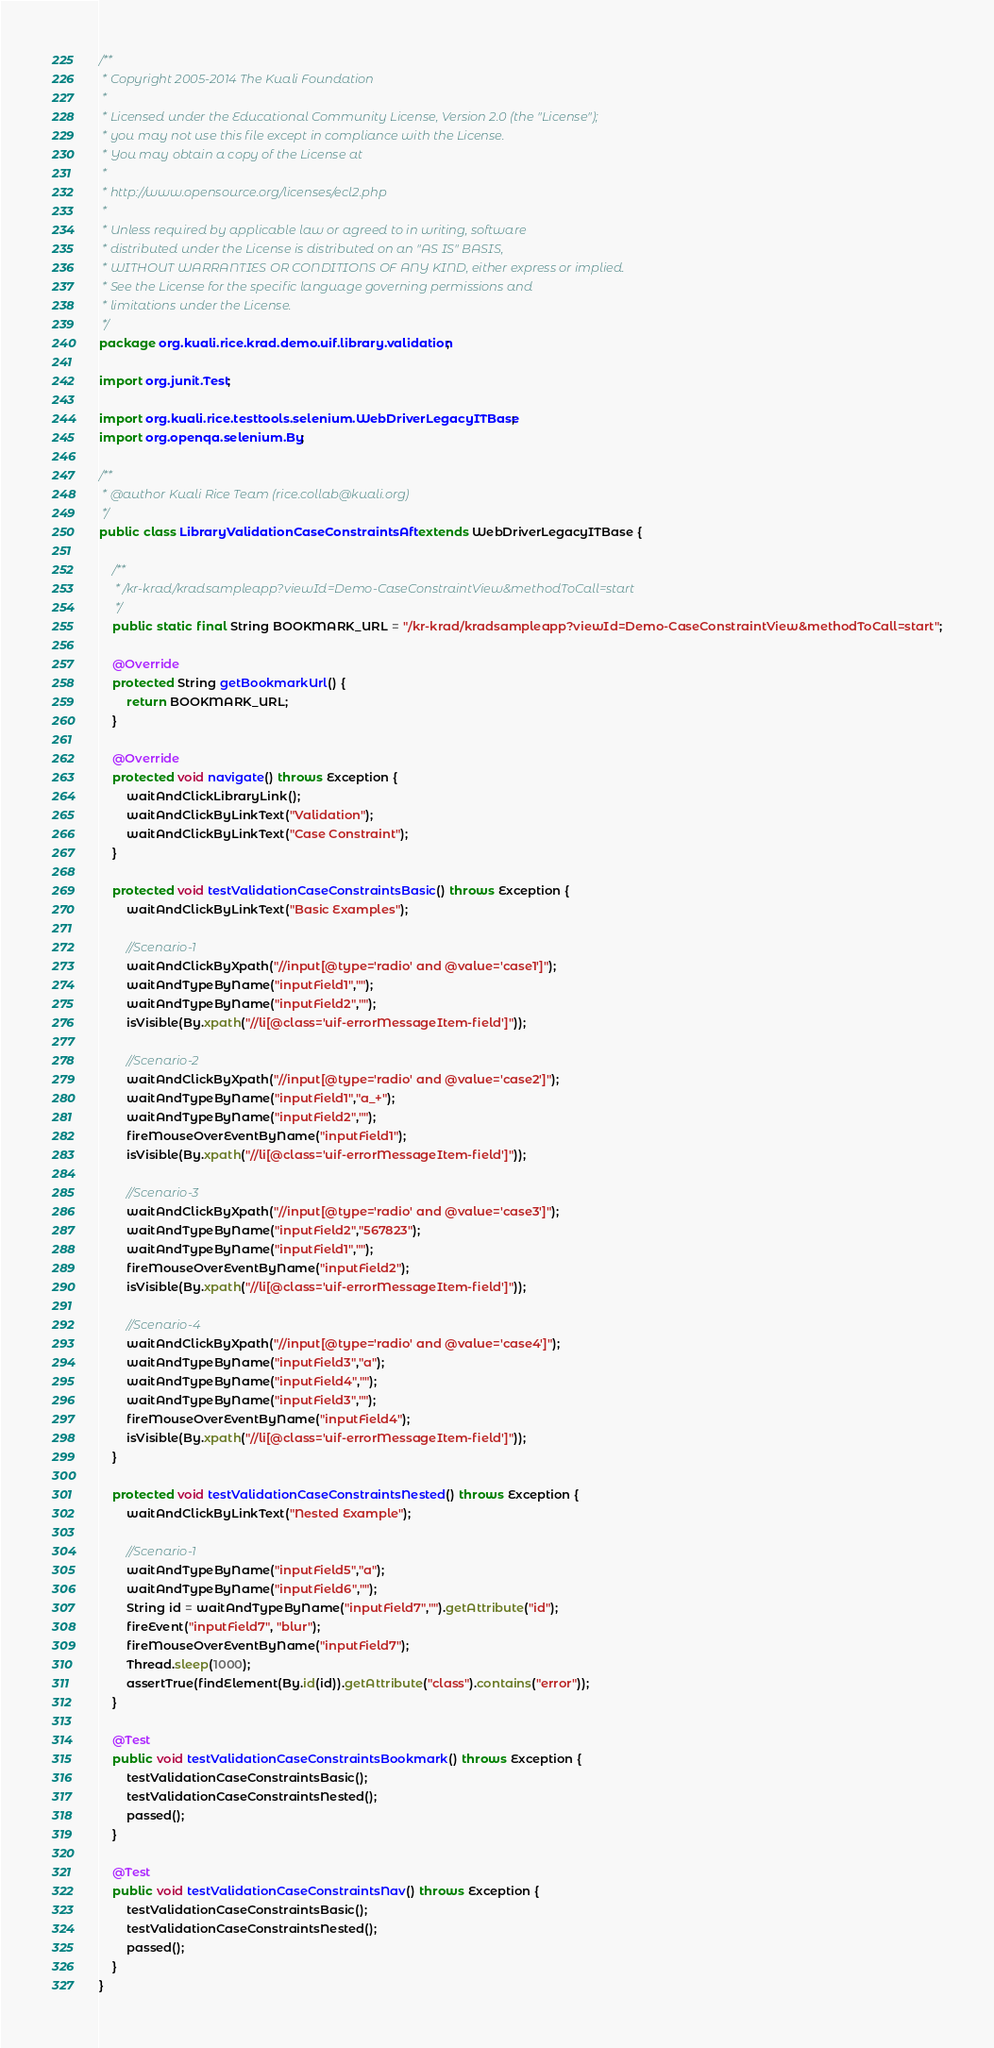Convert code to text. <code><loc_0><loc_0><loc_500><loc_500><_Java_>/**
 * Copyright 2005-2014 The Kuali Foundation
 *
 * Licensed under the Educational Community License, Version 2.0 (the "License");
 * you may not use this file except in compliance with the License.
 * You may obtain a copy of the License at
 *
 * http://www.opensource.org/licenses/ecl2.php
 *
 * Unless required by applicable law or agreed to in writing, software
 * distributed under the License is distributed on an "AS IS" BASIS,
 * WITHOUT WARRANTIES OR CONDITIONS OF ANY KIND, either express or implied.
 * See the License for the specific language governing permissions and
 * limitations under the License.
 */
package org.kuali.rice.krad.demo.uif.library.validation;

import org.junit.Test;

import org.kuali.rice.testtools.selenium.WebDriverLegacyITBase;
import org.openqa.selenium.By;

/**
 * @author Kuali Rice Team (rice.collab@kuali.org)
 */
public class LibraryValidationCaseConstraintsAft extends WebDriverLegacyITBase {

    /**
     * /kr-krad/kradsampleapp?viewId=Demo-CaseConstraintView&methodToCall=start
     */
    public static final String BOOKMARK_URL = "/kr-krad/kradsampleapp?viewId=Demo-CaseConstraintView&methodToCall=start";

    @Override
    protected String getBookmarkUrl() {
        return BOOKMARK_URL;
    }

    @Override
    protected void navigate() throws Exception {
        waitAndClickLibraryLink();
        waitAndClickByLinkText("Validation");
        waitAndClickByLinkText("Case Constraint");
    }

    protected void testValidationCaseConstraintsBasic() throws Exception {
        waitAndClickByLinkText("Basic Examples");

        //Scenario-1
        waitAndClickByXpath("//input[@type='radio' and @value='case1']");
        waitAndTypeByName("inputField1","");
        waitAndTypeByName("inputField2","");
        isVisible(By.xpath("//li[@class='uif-errorMessageItem-field']"));
      
        //Scenario-2
        waitAndClickByXpath("//input[@type='radio' and @value='case2']");
        waitAndTypeByName("inputField1","a_+");
        waitAndTypeByName("inputField2","");
        fireMouseOverEventByName("inputField1");
        isVisible(By.xpath("//li[@class='uif-errorMessageItem-field']"));
       
        //Scenario-3
        waitAndClickByXpath("//input[@type='radio' and @value='case3']");
        waitAndTypeByName("inputField2","567823");
        waitAndTypeByName("inputField1","");
        fireMouseOverEventByName("inputField2");
        isVisible(By.xpath("//li[@class='uif-errorMessageItem-field']"));
       
        //Scenario-4
        waitAndClickByXpath("//input[@type='radio' and @value='case4']");
        waitAndTypeByName("inputField3","a");
        waitAndTypeByName("inputField4","");
        waitAndTypeByName("inputField3","");
        fireMouseOverEventByName("inputField4");
        isVisible(By.xpath("//li[@class='uif-errorMessageItem-field']"));
    }
    
    protected void testValidationCaseConstraintsNested() throws Exception {
        waitAndClickByLinkText("Nested Example");
       
        //Scenario-1
        waitAndTypeByName("inputField5","a");
        waitAndTypeByName("inputField6","");
        String id = waitAndTypeByName("inputField7","").getAttribute("id");
        fireEvent("inputField7", "blur");
        fireMouseOverEventByName("inputField7");
        Thread.sleep(1000);
        assertTrue(findElement(By.id(id)).getAttribute("class").contains("error"));
    }
    
    @Test
    public void testValidationCaseConstraintsBookmark() throws Exception {
        testValidationCaseConstraintsBasic();
        testValidationCaseConstraintsNested();
        passed();
    }

    @Test
    public void testValidationCaseConstraintsNav() throws Exception {
        testValidationCaseConstraintsBasic();
        testValidationCaseConstraintsNested();
        passed();
    }
}
</code> 